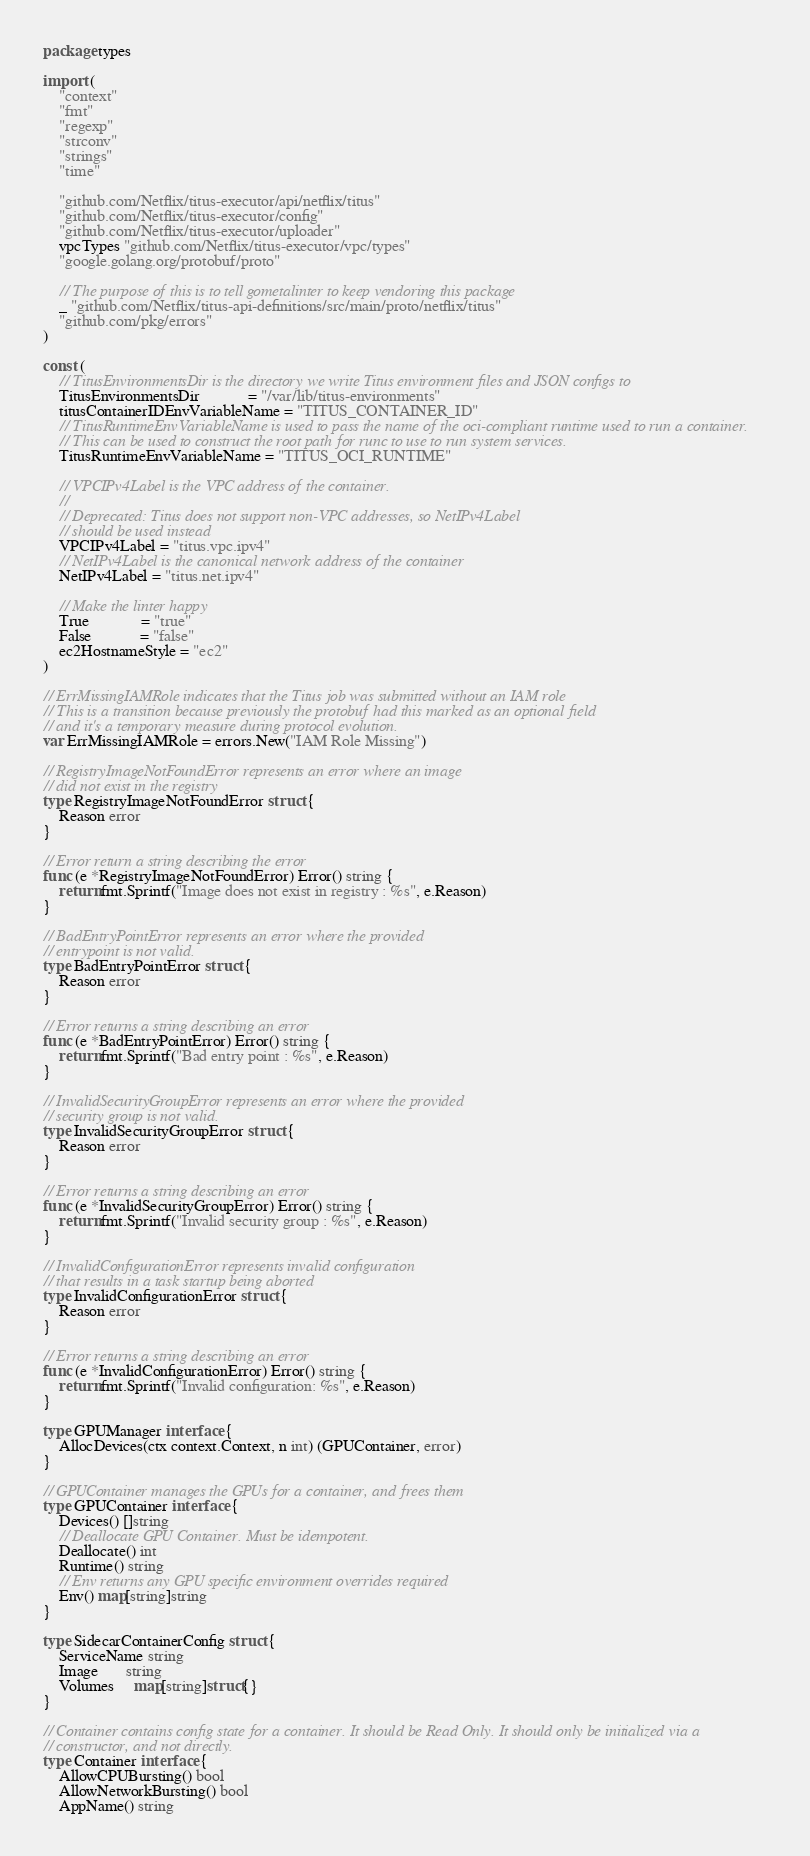<code> <loc_0><loc_0><loc_500><loc_500><_Go_>package types

import (
	"context"
	"fmt"
	"regexp"
	"strconv"
	"strings"
	"time"

	"github.com/Netflix/titus-executor/api/netflix/titus"
	"github.com/Netflix/titus-executor/config"
	"github.com/Netflix/titus-executor/uploader"
	vpcTypes "github.com/Netflix/titus-executor/vpc/types"
	"google.golang.org/protobuf/proto"

	// The purpose of this is to tell gometalinter to keep vendoring this package
	_ "github.com/Netflix/titus-api-definitions/src/main/proto/netflix/titus"
	"github.com/pkg/errors"
)

const (
	// TitusEnvironmentsDir is the directory we write Titus environment files and JSON configs to
	TitusEnvironmentsDir            = "/var/lib/titus-environments"
	titusContainerIDEnvVariableName = "TITUS_CONTAINER_ID"
	// TitusRuntimeEnvVariableName is used to pass the name of the oci-compliant runtime used to run a container.
	// This can be used to construct the root path for runc to use to run system services.
	TitusRuntimeEnvVariableName = "TITUS_OCI_RUNTIME"

	// VPCIPv4Label is the VPC address of the container.
	//
	// Deprecated: Titus does not support non-VPC addresses, so NetIPv4Label
	// should be used instead
	VPCIPv4Label = "titus.vpc.ipv4"
	// NetIPv4Label is the canonical network address of the container
	NetIPv4Label = "titus.net.ipv4"

	// Make the linter happy
	True             = "true"
	False            = "false"
	ec2HostnameStyle = "ec2"
)

// ErrMissingIAMRole indicates that the Titus job was submitted without an IAM role
// This is a transition because previously the protobuf had this marked as an optional field
// and it's a temporary measure during protocol evolution.
var ErrMissingIAMRole = errors.New("IAM Role Missing")

// RegistryImageNotFoundError represents an error where an image
// did not exist in the registry
type RegistryImageNotFoundError struct {
	Reason error
}

// Error return a string describing the error
func (e *RegistryImageNotFoundError) Error() string {
	return fmt.Sprintf("Image does not exist in registry : %s", e.Reason)
}

// BadEntryPointError represents an error where the provided
// entrypoint is not valid.
type BadEntryPointError struct {
	Reason error
}

// Error returns a string describing an error
func (e *BadEntryPointError) Error() string {
	return fmt.Sprintf("Bad entry point : %s", e.Reason)
}

// InvalidSecurityGroupError represents an error where the provided
// security group is not valid.
type InvalidSecurityGroupError struct {
	Reason error
}

// Error returns a string describing an error
func (e *InvalidSecurityGroupError) Error() string {
	return fmt.Sprintf("Invalid security group : %s", e.Reason)
}

// InvalidConfigurationError represents invalid configuration
// that results in a task startup being aborted
type InvalidConfigurationError struct {
	Reason error
}

// Error returns a string describing an error
func (e *InvalidConfigurationError) Error() string {
	return fmt.Sprintf("Invalid configuration: %s", e.Reason)
}

type GPUManager interface {
	AllocDevices(ctx context.Context, n int) (GPUContainer, error)
}

// GPUContainer manages the GPUs for a container, and frees them
type GPUContainer interface {
	Devices() []string
	// Deallocate GPU Container. Must be idempotent.
	Deallocate() int
	Runtime() string
	// Env returns any GPU specific environment overrides required
	Env() map[string]string
}

type SidecarContainerConfig struct {
	ServiceName string
	Image       string
	Volumes     map[string]struct{}
}

// Container contains config state for a container. It should be Read Only. It should only be initialized via a
// constructor, and not directly.
type Container interface {
	AllowCPUBursting() bool
	AllowNetworkBursting() bool
	AppName() string</code> 